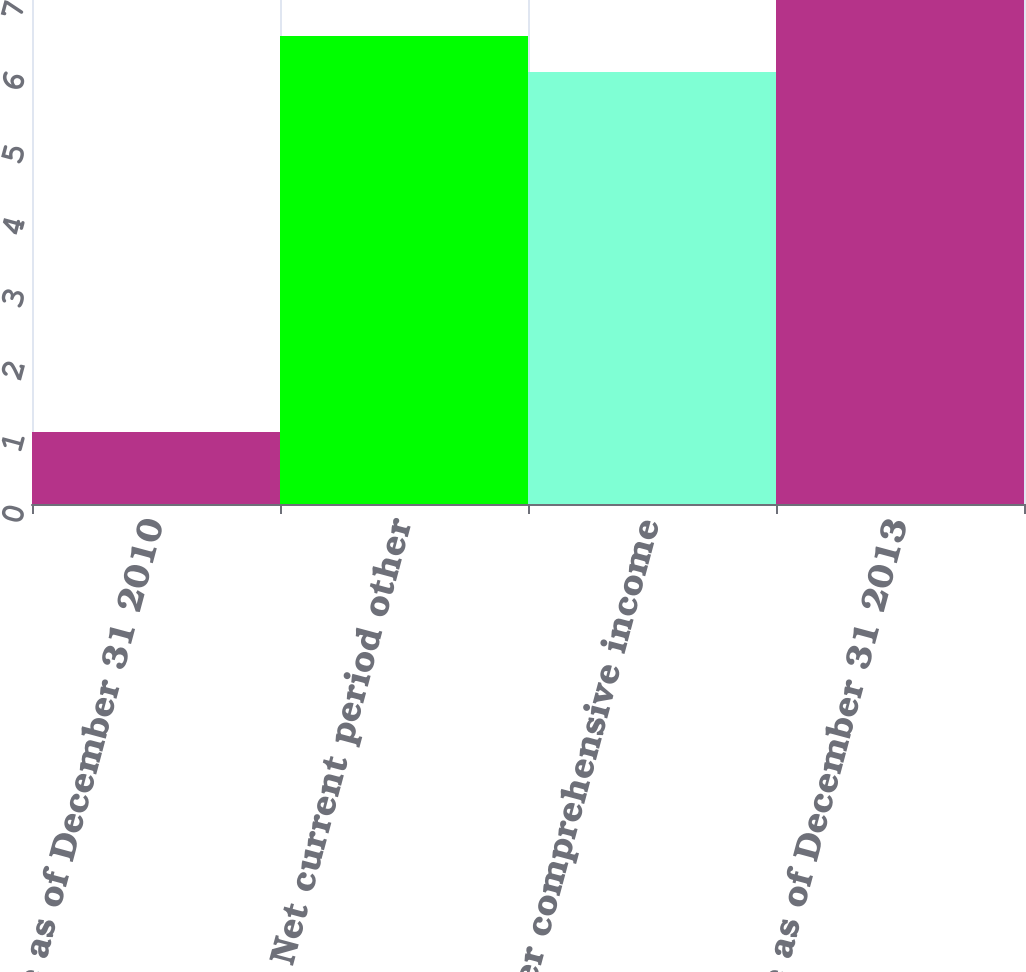Convert chart. <chart><loc_0><loc_0><loc_500><loc_500><bar_chart><fcel>Balance as of December 31 2010<fcel>Net current period other<fcel>Other comprehensive income<fcel>Balance as of December 31 2013<nl><fcel>1<fcel>6.5<fcel>6<fcel>7<nl></chart> 